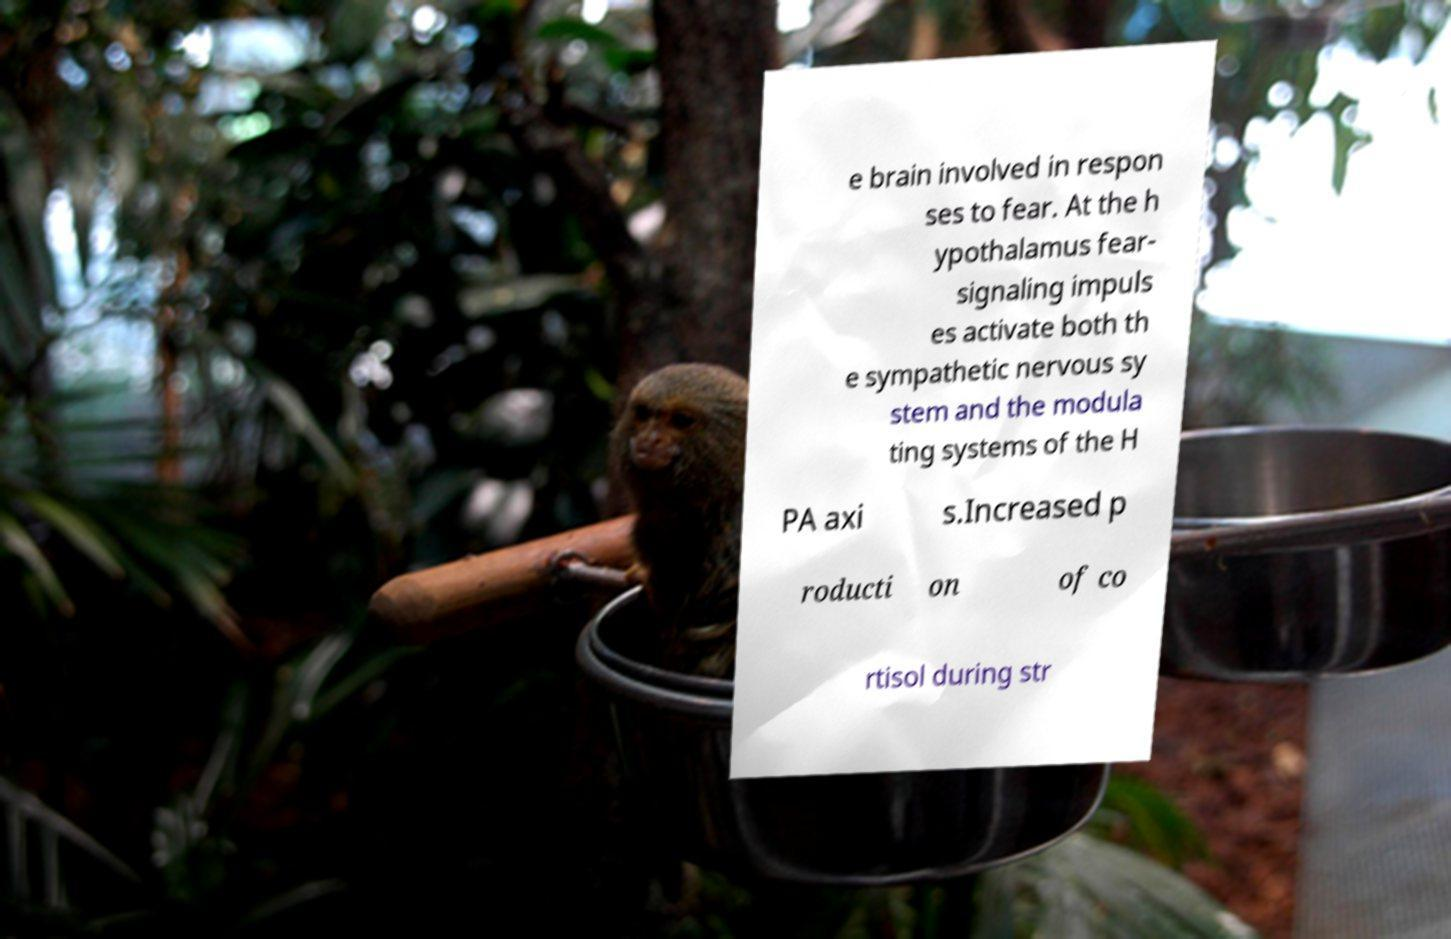Can you read and provide the text displayed in the image?This photo seems to have some interesting text. Can you extract and type it out for me? e brain involved in respon ses to fear. At the h ypothalamus fear- signaling impuls es activate both th e sympathetic nervous sy stem and the modula ting systems of the H PA axi s.Increased p roducti on of co rtisol during str 